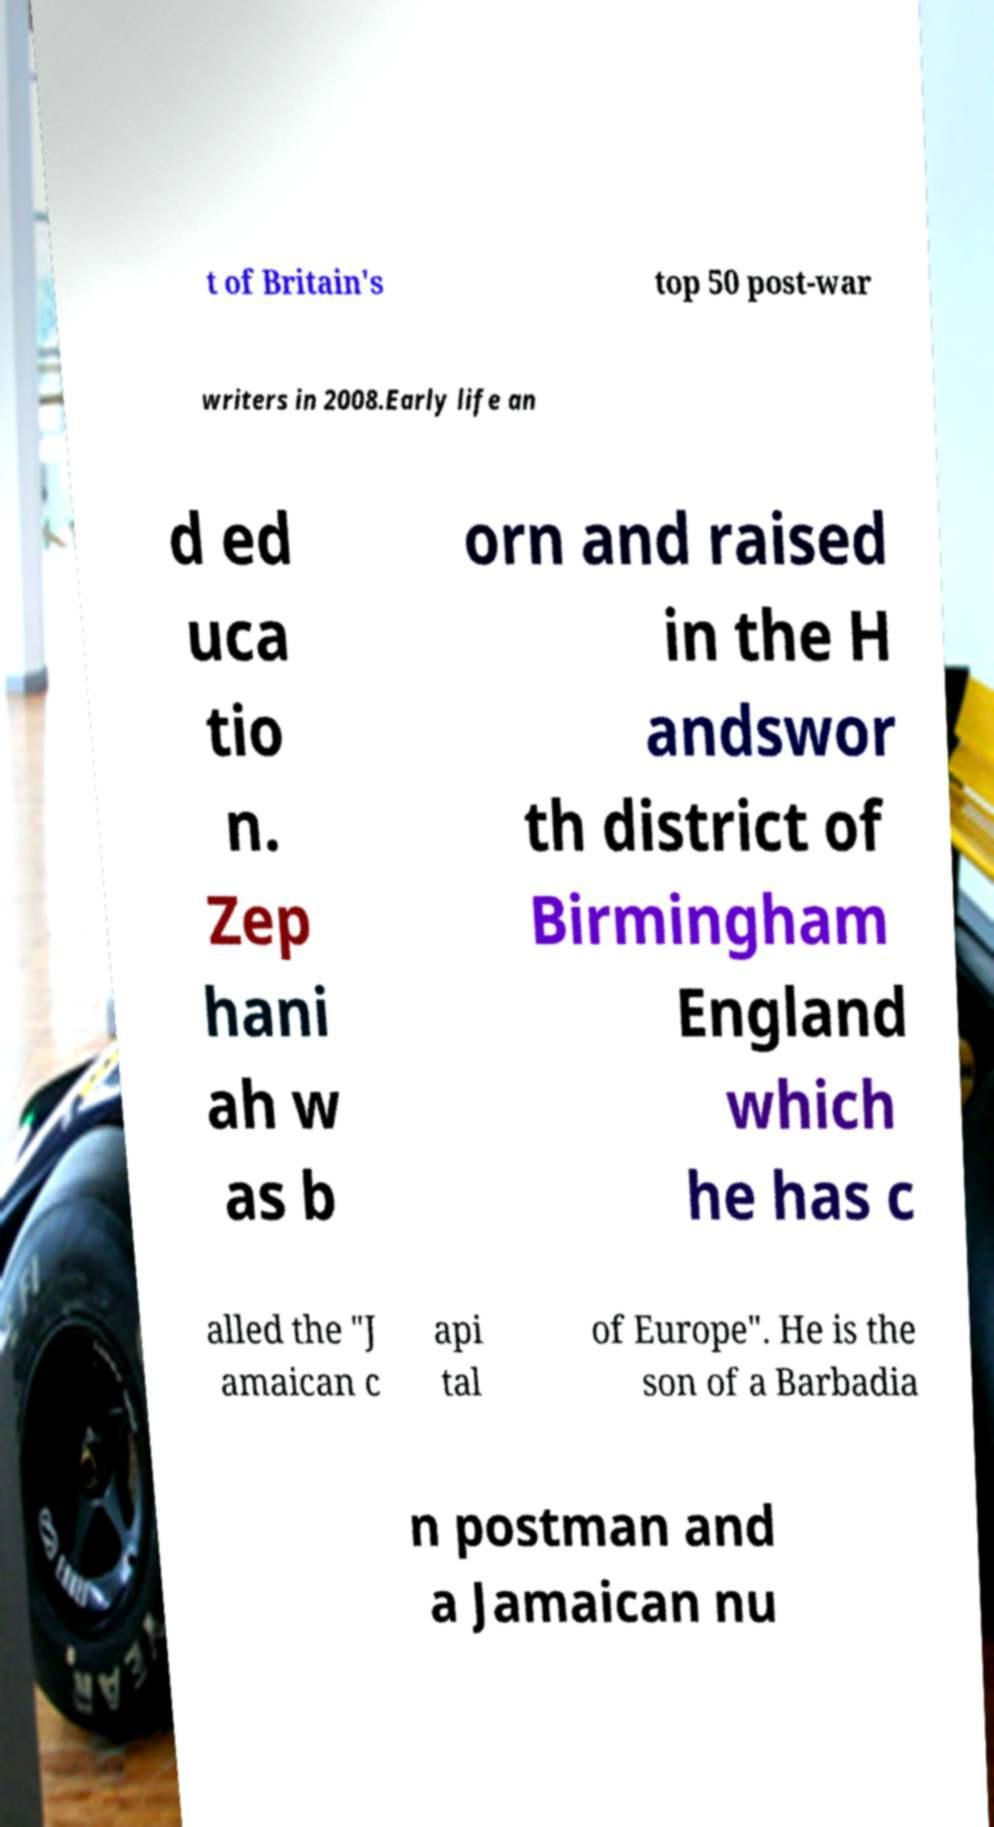Can you read and provide the text displayed in the image?This photo seems to have some interesting text. Can you extract and type it out for me? t of Britain's top 50 post-war writers in 2008.Early life an d ed uca tio n. Zep hani ah w as b orn and raised in the H andswor th district of Birmingham England which he has c alled the "J amaican c api tal of Europe". He is the son of a Barbadia n postman and a Jamaican nu 